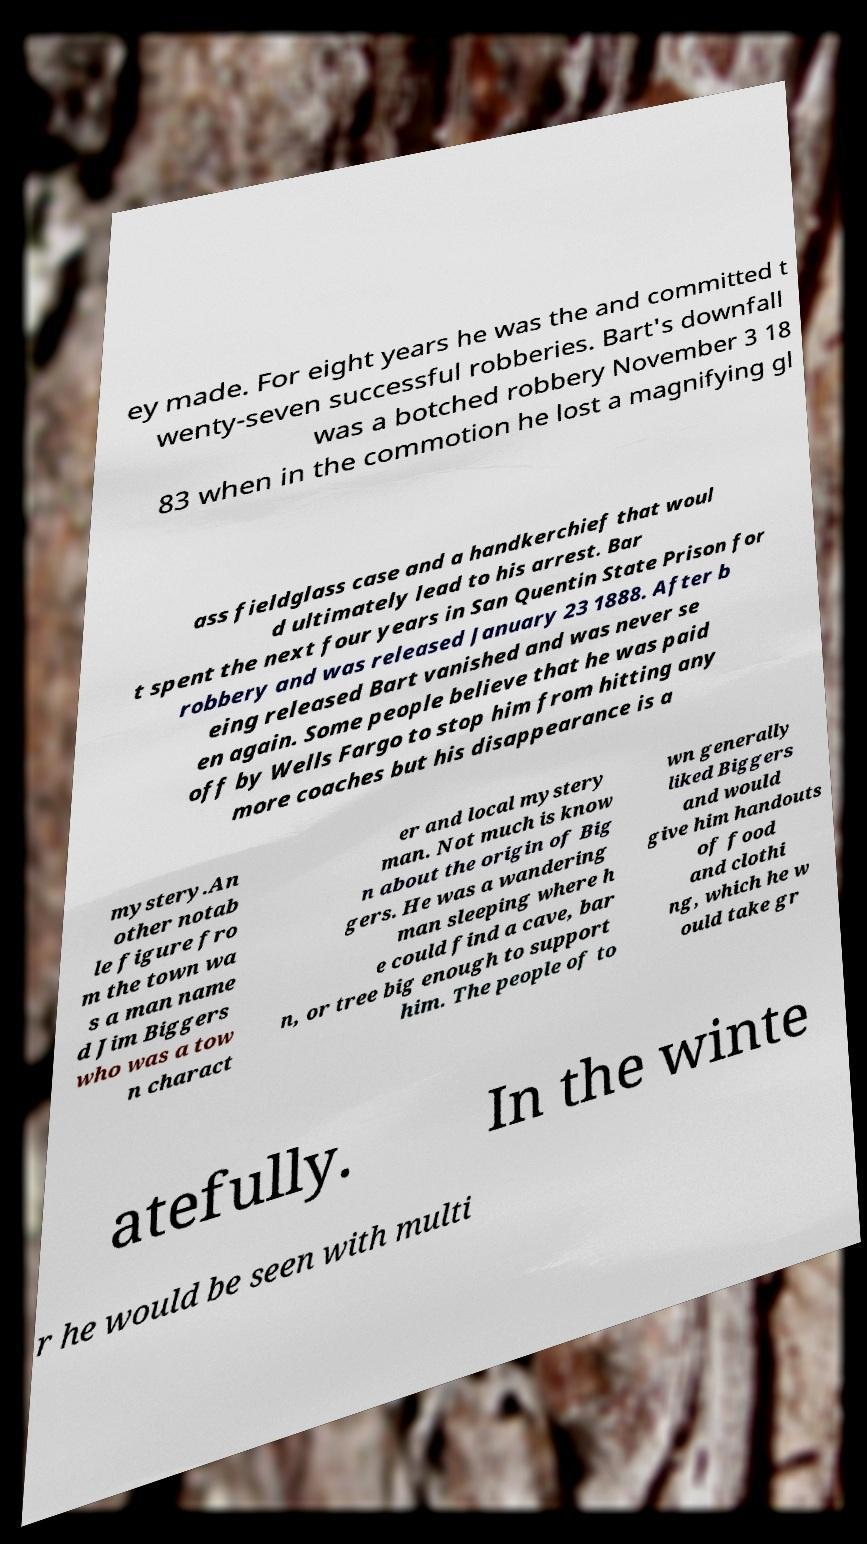Please read and relay the text visible in this image. What does it say? ey made. For eight years he was the and committed t wenty-seven successful robberies. Bart's downfall was a botched robbery November 3 18 83 when in the commotion he lost a magnifying gl ass fieldglass case and a handkerchief that woul d ultimately lead to his arrest. Bar t spent the next four years in San Quentin State Prison for robbery and was released January 23 1888. After b eing released Bart vanished and was never se en again. Some people believe that he was paid off by Wells Fargo to stop him from hitting any more coaches but his disappearance is a mystery.An other notab le figure fro m the town wa s a man name d Jim Biggers who was a tow n charact er and local mystery man. Not much is know n about the origin of Big gers. He was a wandering man sleeping where h e could find a cave, bar n, or tree big enough to support him. The people of to wn generally liked Biggers and would give him handouts of food and clothi ng, which he w ould take gr atefully. In the winte r he would be seen with multi 